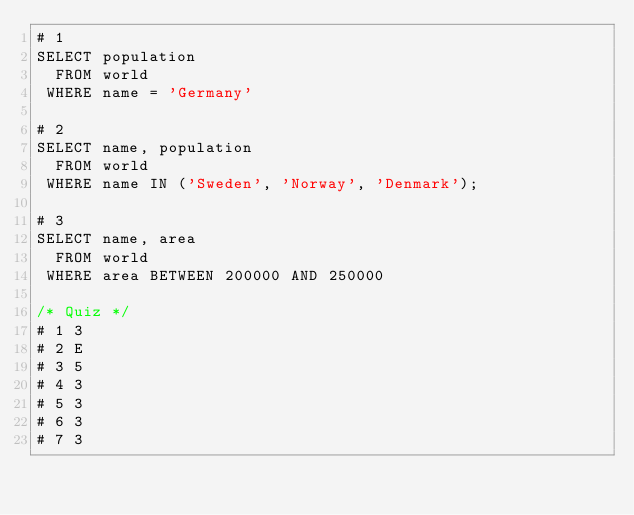<code> <loc_0><loc_0><loc_500><loc_500><_SQL_># 1
SELECT population
  FROM world
 WHERE name = 'Germany'

# 2
SELECT name, population
  FROM world
 WHERE name IN ('Sweden', 'Norway', 'Denmark');

# 3
SELECT name, area
  FROM world
 WHERE area BETWEEN 200000 AND 250000

/* Quiz */
# 1 3
# 2 E
# 3 5
# 4 3
# 5 3
# 6 3
# 7 3
</code> 